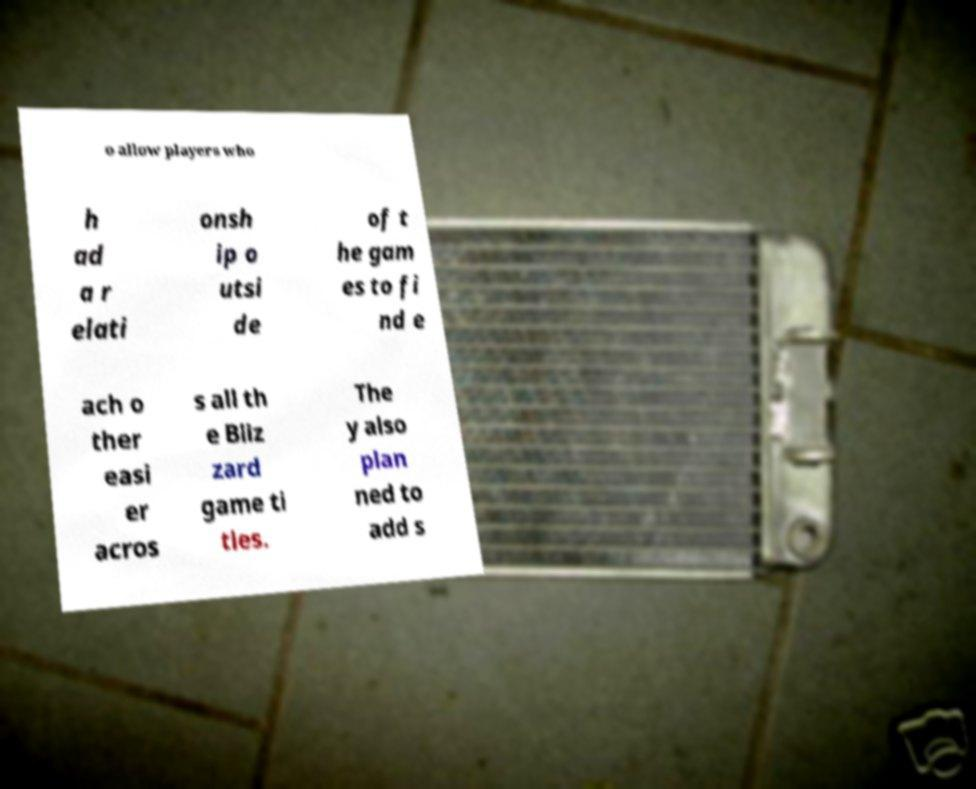Could you assist in decoding the text presented in this image and type it out clearly? o allow players who h ad a r elati onsh ip o utsi de of t he gam es to fi nd e ach o ther easi er acros s all th e Bliz zard game ti tles. The y also plan ned to add s 